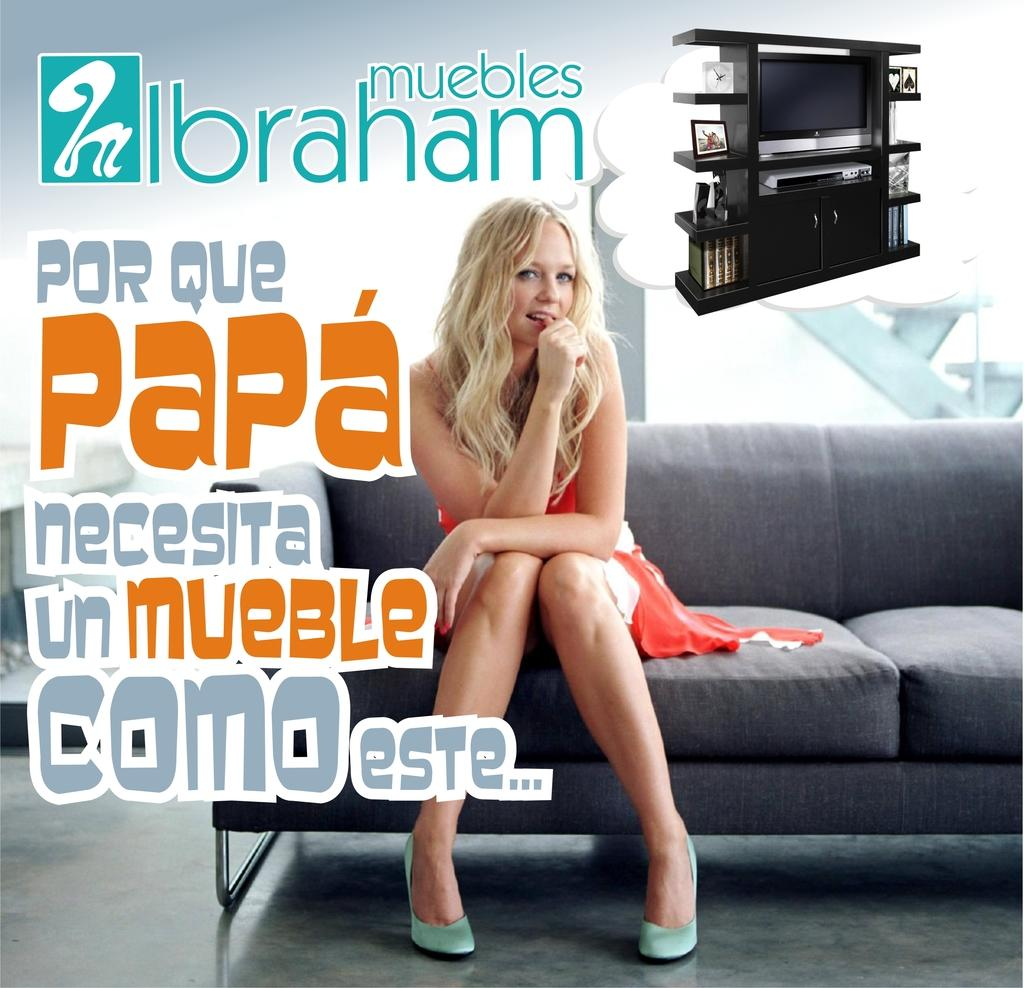<image>
Create a compact narrative representing the image presented. attractive woman sitting on a couch from muebles ibraham and she is saying por que papa necesita unmueble como este 